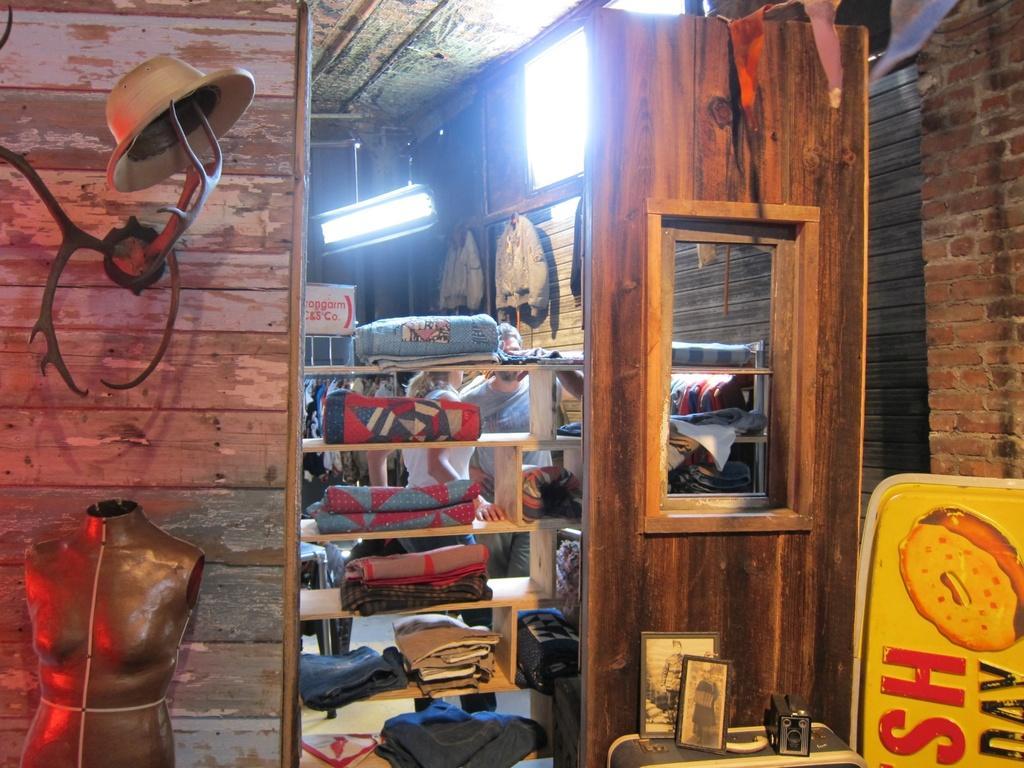Can you describe this image briefly? In this picture we can see the blankets in the wooden racks. We can see the ceiling, light, photo frames, mannequin, paper flags, board, clothes, wall and few objects. 